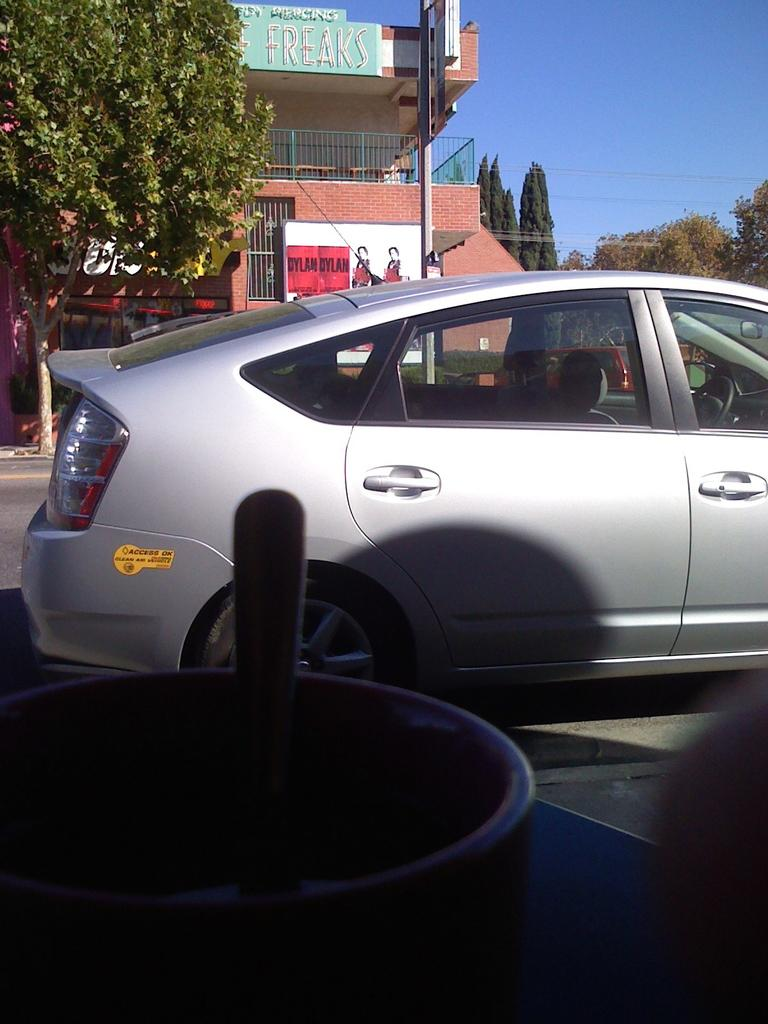What is on the table in the image? There is a bowl on a table in the image. What type of vehicle is present in the image? There is a car in the image. What type of building is visible in the image? There is a house in the image. What is associated with the house in the image? There are boards associated with the house. What type of vegetation can be seen in the image? There are trees visible in the image. What day of the week is it in the picture? The day of the week is not mentioned or depicted, so it cannot be determined. Is there a rifle visible in the picture? No, there is no rifle or any weapon present. 